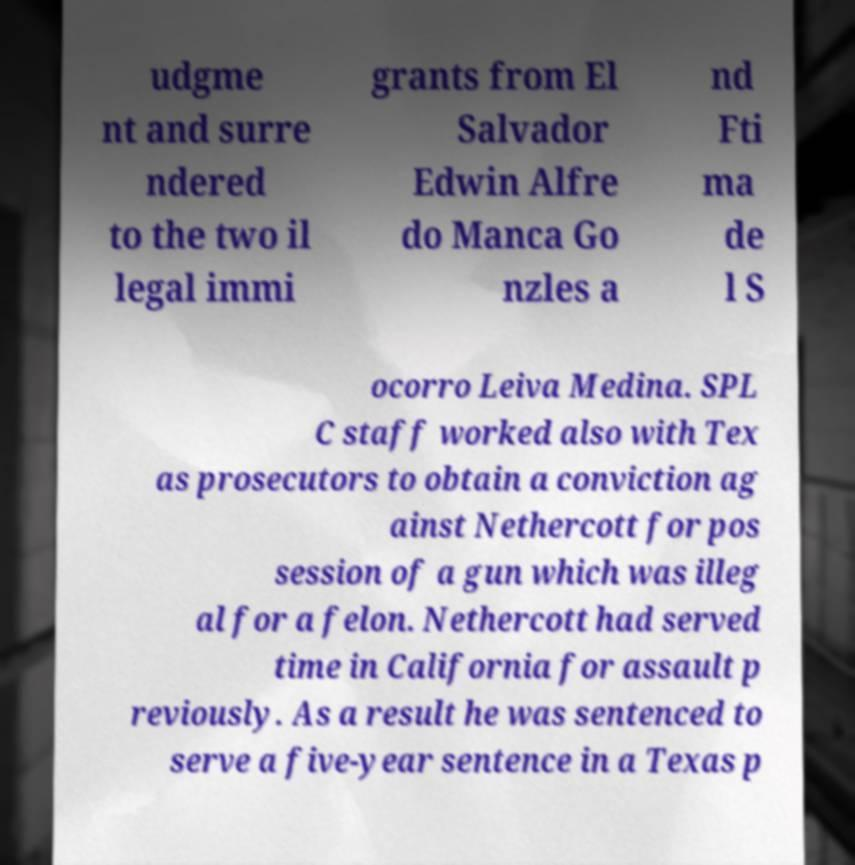Can you accurately transcribe the text from the provided image for me? udgme nt and surre ndered to the two il legal immi grants from El Salvador Edwin Alfre do Manca Go nzles a nd Fti ma de l S ocorro Leiva Medina. SPL C staff worked also with Tex as prosecutors to obtain a conviction ag ainst Nethercott for pos session of a gun which was illeg al for a felon. Nethercott had served time in California for assault p reviously. As a result he was sentenced to serve a five-year sentence in a Texas p 